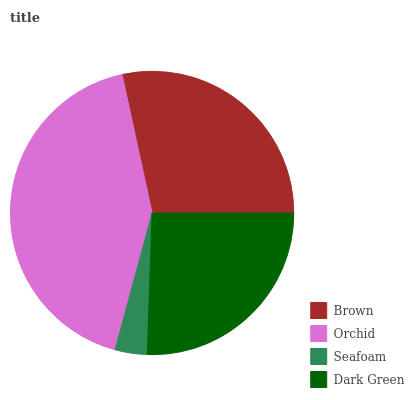Is Seafoam the minimum?
Answer yes or no. Yes. Is Orchid the maximum?
Answer yes or no. Yes. Is Orchid the minimum?
Answer yes or no. No. Is Seafoam the maximum?
Answer yes or no. No. Is Orchid greater than Seafoam?
Answer yes or no. Yes. Is Seafoam less than Orchid?
Answer yes or no. Yes. Is Seafoam greater than Orchid?
Answer yes or no. No. Is Orchid less than Seafoam?
Answer yes or no. No. Is Brown the high median?
Answer yes or no. Yes. Is Dark Green the low median?
Answer yes or no. Yes. Is Seafoam the high median?
Answer yes or no. No. Is Brown the low median?
Answer yes or no. No. 